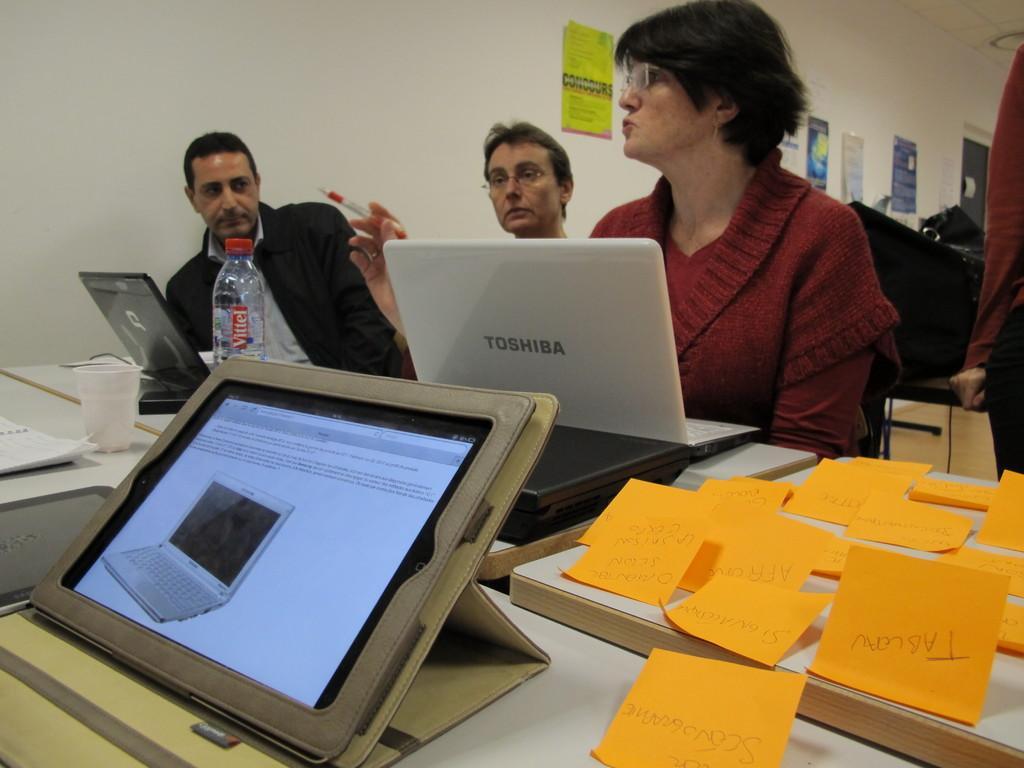Please provide a concise description of this image. In this image there is a woman , man , another man sitting and in table there are papers, wooden board , I pad, laptop, glass, bottle and in back ground there are group of persons standing, papers stick to wall. 